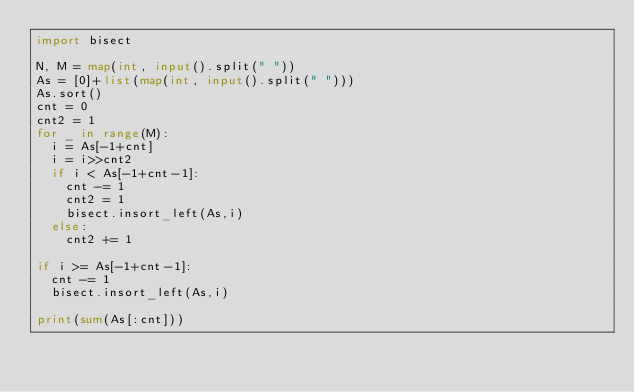Convert code to text. <code><loc_0><loc_0><loc_500><loc_500><_Python_>import bisect
 
N, M = map(int, input().split(" "))
As = [0]+list(map(int, input().split(" ")))
As.sort()
cnt = 0
cnt2 = 1
for _ in range(M):
  i = As[-1+cnt]  
  i = i>>cnt2
  if i < As[-1+cnt-1]:
    cnt -= 1
    cnt2 = 1
    bisect.insort_left(As,i)
  else:
    cnt2 += 1

if i >= As[-1+cnt-1]:
  cnt -= 1
  bisect.insort_left(As,i)
  
print(sum(As[:cnt]))</code> 